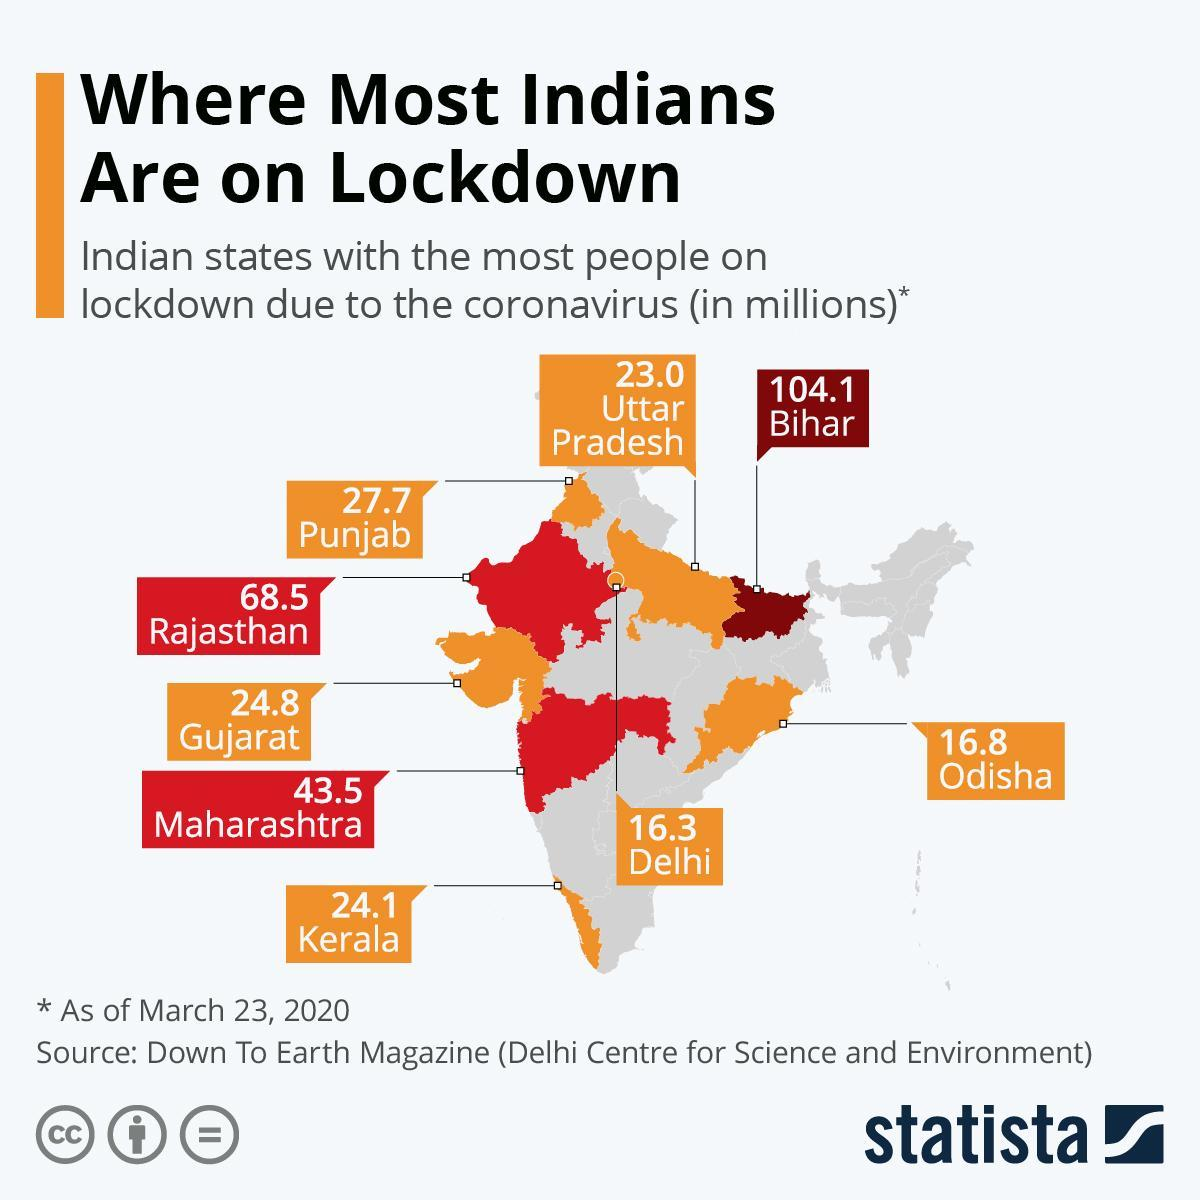Which states have more than 50 million people during lockdown?
Answer the question with a short phrase. Maharashtra, Rajasthan, Bihar 